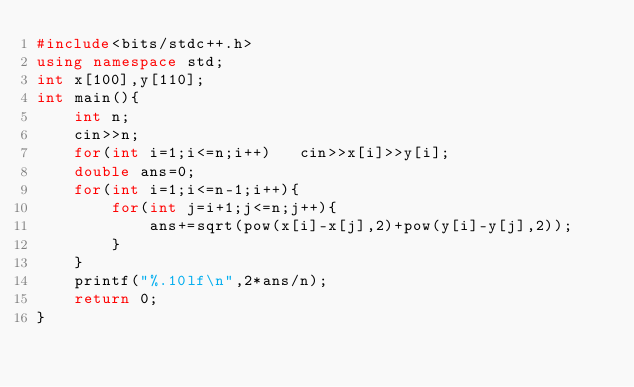<code> <loc_0><loc_0><loc_500><loc_500><_C++_>#include<bits/stdc++.h>
using namespace std;
int x[100],y[110];
int main(){
    int n;
    cin>>n;
    for(int i=1;i<=n;i++)   cin>>x[i]>>y[i];
    double ans=0;
    for(int i=1;i<=n-1;i++){
        for(int j=i+1;j<=n;j++){
            ans+=sqrt(pow(x[i]-x[j],2)+pow(y[i]-y[j],2));
        }
    }
    printf("%.10lf\n",2*ans/n);
    return 0;
}
</code> 